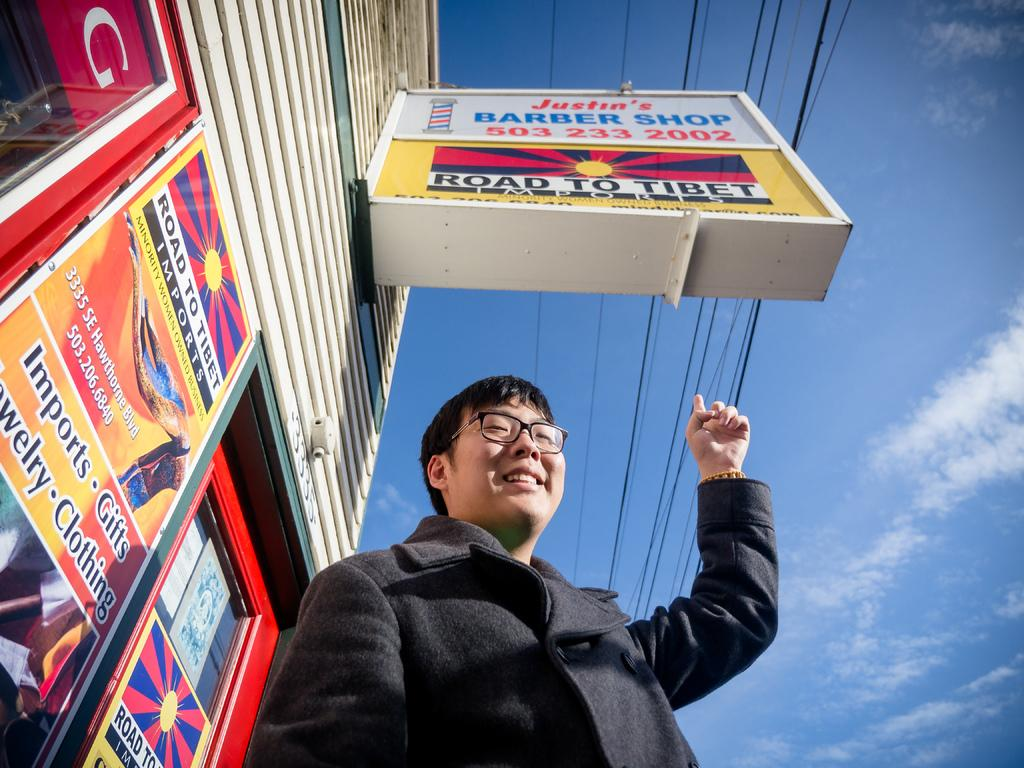<image>
Render a clear and concise summary of the photo. A man points at a Road to Tibet sign on the street. 